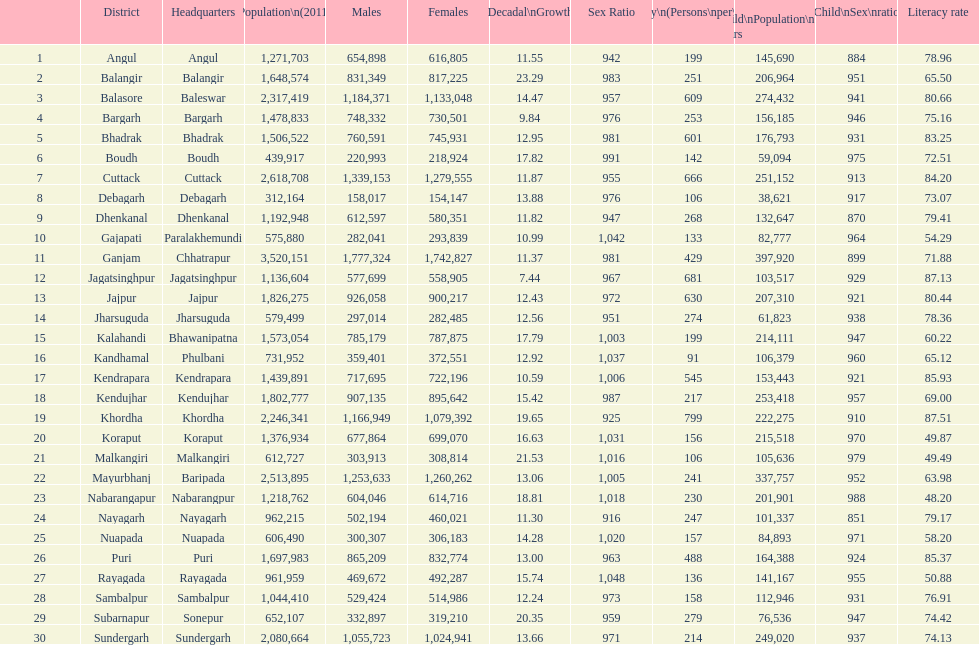From 2001-2011, which district had the smallest population expansion? Jagatsinghpur. 